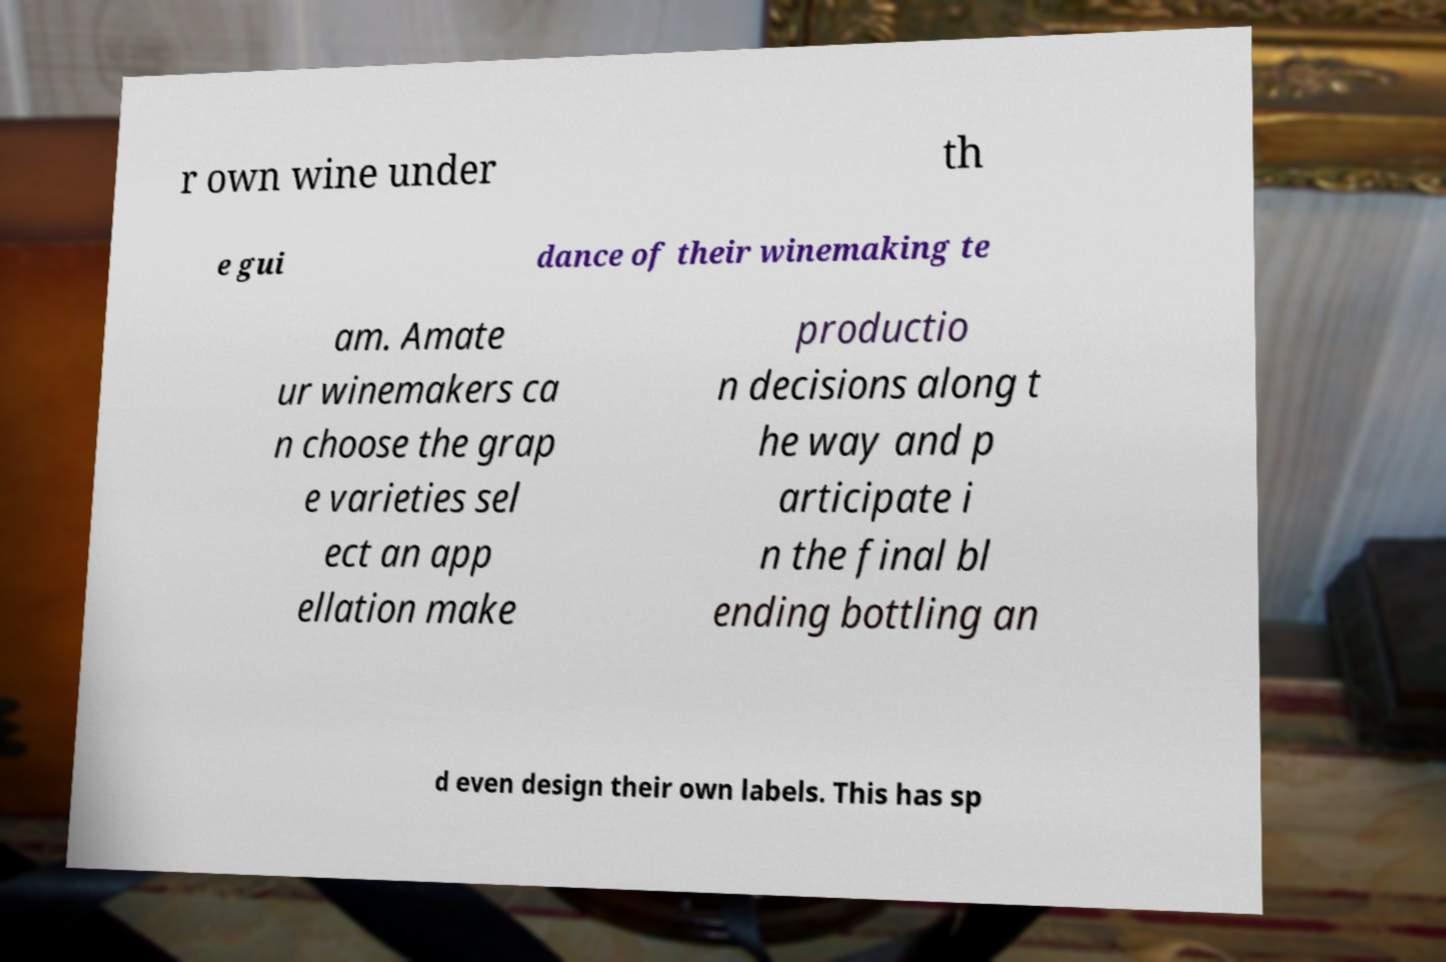Please identify and transcribe the text found in this image. r own wine under th e gui dance of their winemaking te am. Amate ur winemakers ca n choose the grap e varieties sel ect an app ellation make productio n decisions along t he way and p articipate i n the final bl ending bottling an d even design their own labels. This has sp 